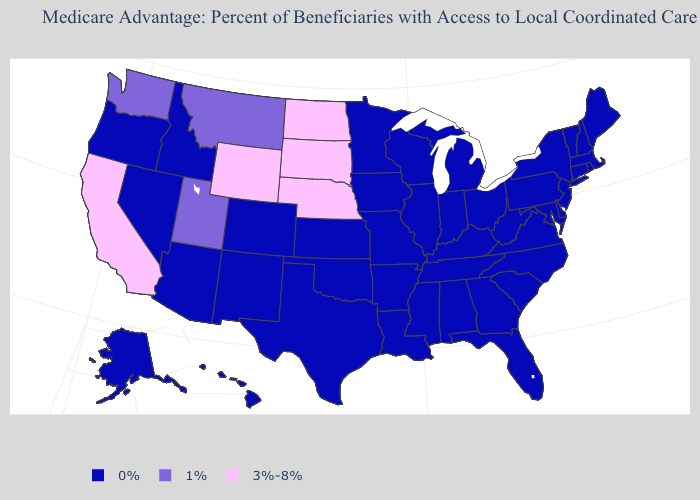What is the value of Ohio?
Short answer required. 0%. Among the states that border Tennessee , which have the highest value?
Write a very short answer. Georgia, Kentucky, Missouri, Mississippi, North Carolina, Virginia, Alabama, Arkansas. Which states have the lowest value in the USA?
Short answer required. Colorado, Connecticut, Delaware, Florida, Georgia, Hawaii, Iowa, Idaho, Illinois, Indiana, Kansas, Kentucky, Louisiana, Massachusetts, Maryland, Maine, Michigan, Minnesota, Missouri, Mississippi, North Carolina, New Hampshire, New Jersey, New Mexico, Nevada, New York, Ohio, Oklahoma, Oregon, Pennsylvania, Rhode Island, South Carolina, Alaska, Tennessee, Texas, Virginia, Vermont, Wisconsin, West Virginia, Alabama, Arkansas, Arizona. Which states have the highest value in the USA?
Quick response, please. California, North Dakota, Nebraska, South Dakota, Wyoming. Name the states that have a value in the range 0%?
Be succinct. Colorado, Connecticut, Delaware, Florida, Georgia, Hawaii, Iowa, Idaho, Illinois, Indiana, Kansas, Kentucky, Louisiana, Massachusetts, Maryland, Maine, Michigan, Minnesota, Missouri, Mississippi, North Carolina, New Hampshire, New Jersey, New Mexico, Nevada, New York, Ohio, Oklahoma, Oregon, Pennsylvania, Rhode Island, South Carolina, Alaska, Tennessee, Texas, Virginia, Vermont, Wisconsin, West Virginia, Alabama, Arkansas, Arizona. Among the states that border Minnesota , which have the lowest value?
Quick response, please. Iowa, Wisconsin. Which states have the highest value in the USA?
Keep it brief. California, North Dakota, Nebraska, South Dakota, Wyoming. What is the value of Iowa?
Give a very brief answer. 0%. Name the states that have a value in the range 0%?
Concise answer only. Colorado, Connecticut, Delaware, Florida, Georgia, Hawaii, Iowa, Idaho, Illinois, Indiana, Kansas, Kentucky, Louisiana, Massachusetts, Maryland, Maine, Michigan, Minnesota, Missouri, Mississippi, North Carolina, New Hampshire, New Jersey, New Mexico, Nevada, New York, Ohio, Oklahoma, Oregon, Pennsylvania, Rhode Island, South Carolina, Alaska, Tennessee, Texas, Virginia, Vermont, Wisconsin, West Virginia, Alabama, Arkansas, Arizona. Does the map have missing data?
Write a very short answer. No. Is the legend a continuous bar?
Keep it brief. No. Does Kentucky have the same value as Ohio?
Concise answer only. Yes. Which states hav the highest value in the South?
Answer briefly. Delaware, Florida, Georgia, Kentucky, Louisiana, Maryland, Mississippi, North Carolina, Oklahoma, South Carolina, Tennessee, Texas, Virginia, West Virginia, Alabama, Arkansas. What is the value of South Carolina?
Be succinct. 0%. Which states have the lowest value in the Northeast?
Be succinct. Connecticut, Massachusetts, Maine, New Hampshire, New Jersey, New York, Pennsylvania, Rhode Island, Vermont. 